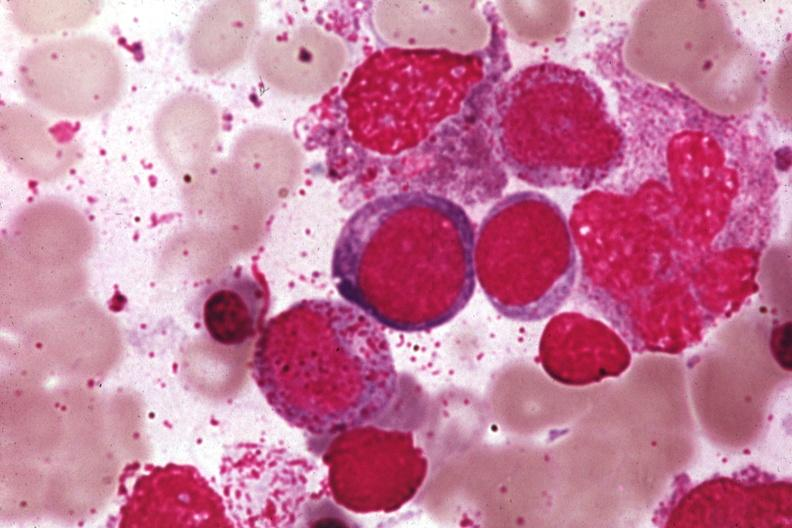does this image show wrights?
Answer the question using a single word or phrase. Yes 